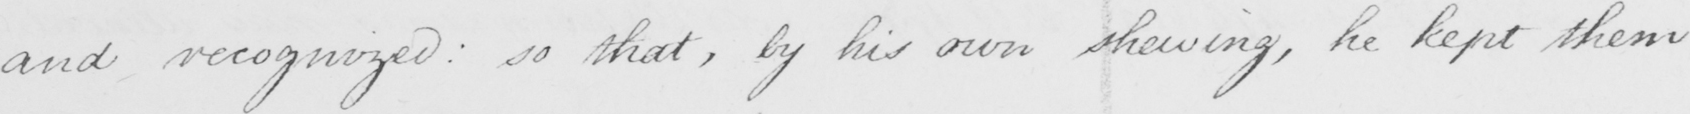What is written in this line of handwriting? and recognized so that , by his own shewing , he kept them 